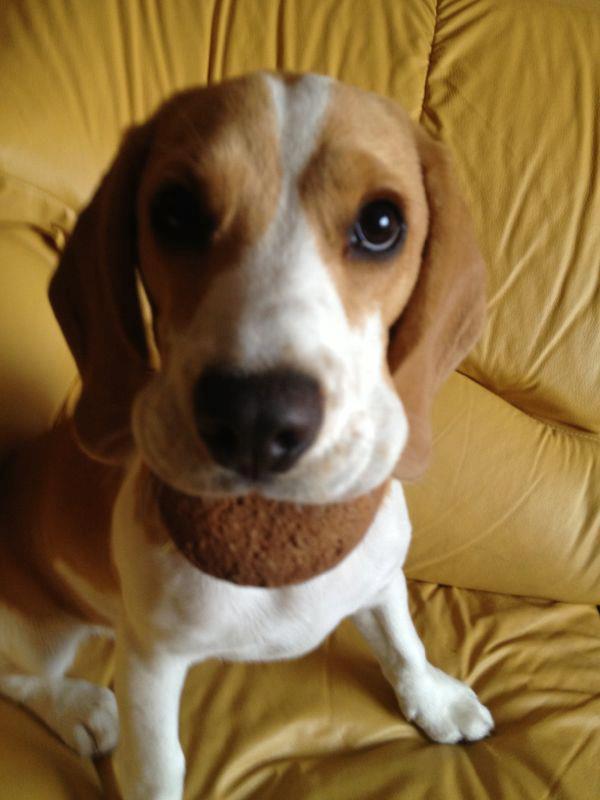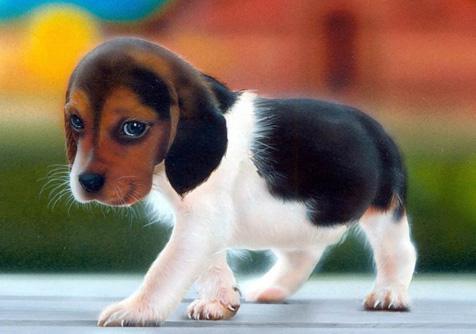The first image is the image on the left, the second image is the image on the right. For the images displayed, is the sentence "beagles are sitting or standing in green grass" factually correct? Answer yes or no. No. The first image is the image on the left, the second image is the image on the right. Analyze the images presented: Is the assertion "An image shows a dog looking up at the camera with a semi-circular shape under its nose." valid? Answer yes or no. Yes. 